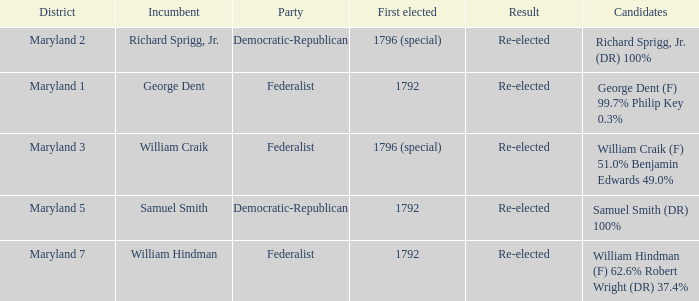What is the party when the incumbent is samuel smith? Democratic-Republican. 